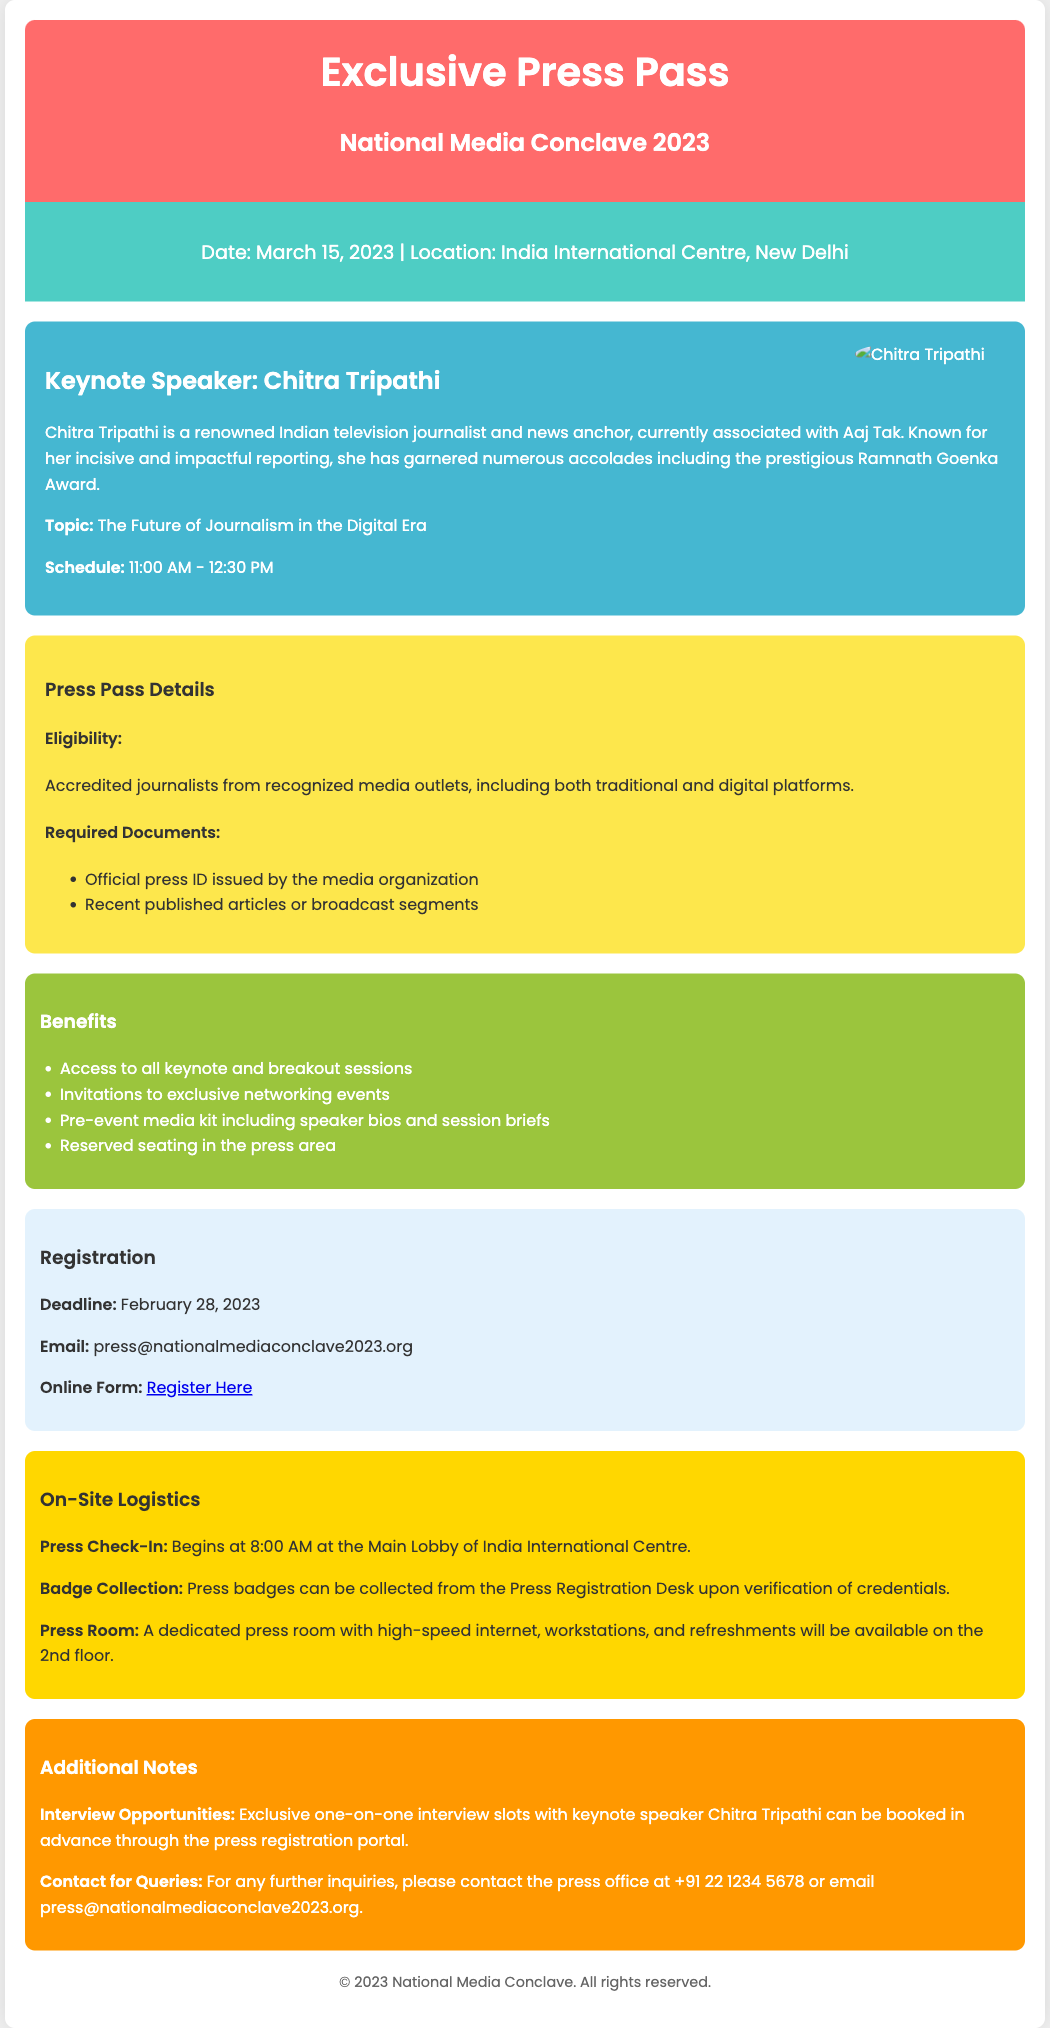What is the date of the event? The date of the event is mentioned in the event details section.
Answer: March 15, 2023 Where is the event located? The location of the event is specified in the event details section.
Answer: India International Centre, New Delhi Who is the keynote speaker? The keynote speaker's name is provided in the keynote speaker section.
Answer: Chitra Tripathi What is the topic of Chitra Tripathi's keynote speech? The topic is found in the keynote speaker section just below her name.
Answer: The Future of Journalism in the Digital Era What is the registration deadline? The registration deadline is listed in the registration section.
Answer: February 28, 2023 How many benefits are mentioned in the benefits section? The number of benefits can be counted from the bulleted list in the benefits section.
Answer: Four Is there an opportunity for interviews with Chitra Tripathi? The document mentions this in the additional notes section regarding exclusive interview slots.
Answer: Yes What time does the press check-in begin? The time for press check-in is detailed in the on-site logistics section.
Answer: 8:00 AM What is the contact number for queries? The contact number is provided in the additional notes section.
Answer: +91 22 1234 5678 